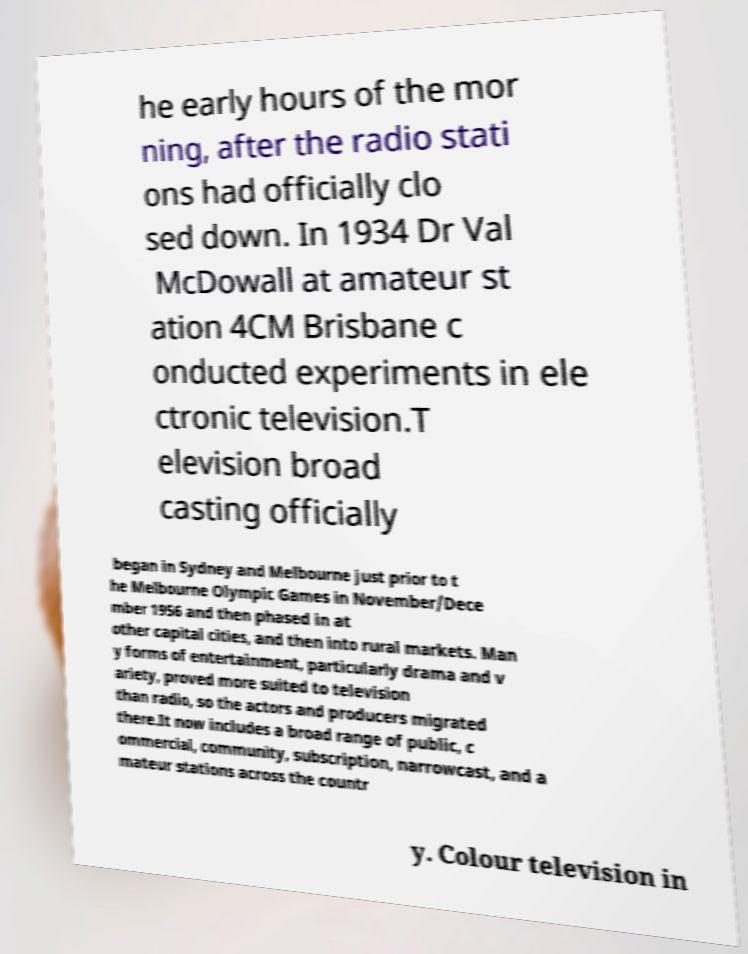Can you accurately transcribe the text from the provided image for me? he early hours of the mor ning, after the radio stati ons had officially clo sed down. In 1934 Dr Val McDowall at amateur st ation 4CM Brisbane c onducted experiments in ele ctronic television.T elevision broad casting officially began in Sydney and Melbourne just prior to t he Melbourne Olympic Games in November/Dece mber 1956 and then phased in at other capital cities, and then into rural markets. Man y forms of entertainment, particularly drama and v ariety, proved more suited to television than radio, so the actors and producers migrated there.It now includes a broad range of public, c ommercial, community, subscription, narrowcast, and a mateur stations across the countr y. Colour television in 